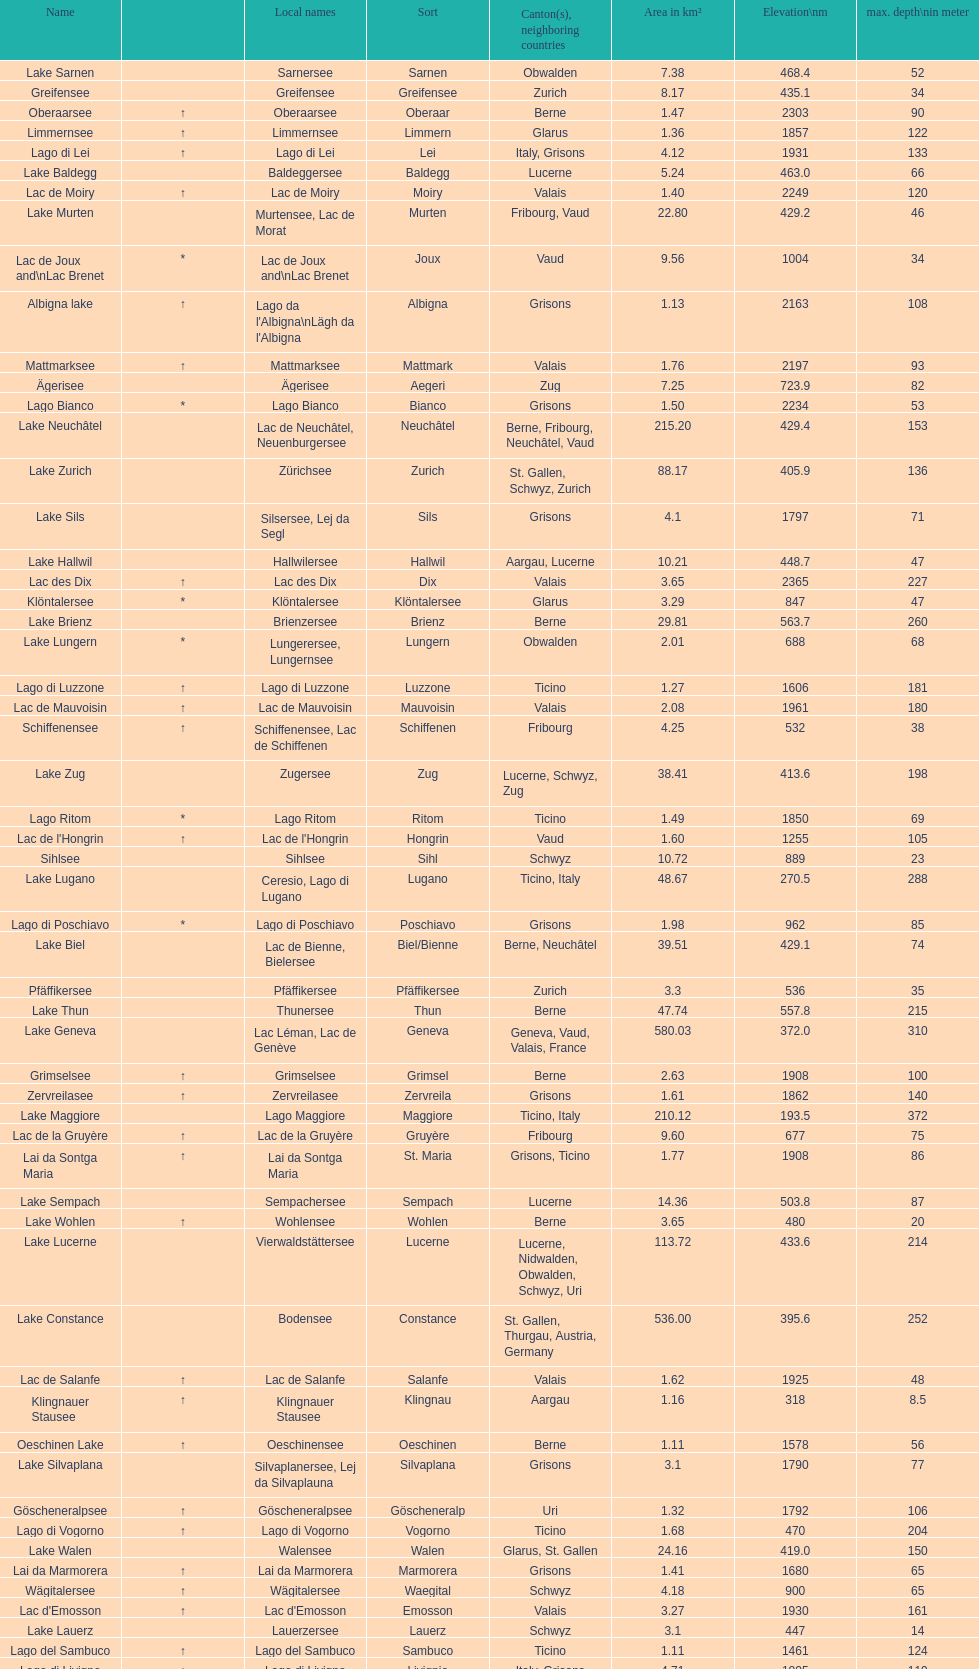Parse the full table. {'header': ['Name', '', 'Local names', 'Sort', 'Canton(s), neighboring countries', 'Area in km²', 'Elevation\\nm', 'max. depth\\nin meter'], 'rows': [['Lake Sarnen', '', 'Sarnersee', 'Sarnen', 'Obwalden', '7.38', '468.4', '52'], ['Greifensee', '', 'Greifensee', 'Greifensee', 'Zurich', '8.17', '435.1', '34'], ['Oberaarsee', '↑', 'Oberaarsee', 'Oberaar', 'Berne', '1.47', '2303', '90'], ['Limmernsee', '↑', 'Limmernsee', 'Limmern', 'Glarus', '1.36', '1857', '122'], ['Lago di Lei', '↑', 'Lago di Lei', 'Lei', 'Italy, Grisons', '4.12', '1931', '133'], ['Lake Baldegg', '', 'Baldeggersee', 'Baldegg', 'Lucerne', '5.24', '463.0', '66'], ['Lac de Moiry', '↑', 'Lac de Moiry', 'Moiry', 'Valais', '1.40', '2249', '120'], ['Lake Murten', '', 'Murtensee, Lac de Morat', 'Murten', 'Fribourg, Vaud', '22.80', '429.2', '46'], ['Lac de Joux and\\nLac Brenet', '*', 'Lac de Joux and\\nLac Brenet', 'Joux', 'Vaud', '9.56', '1004', '34'], ['Albigna lake', '↑', "Lago da l'Albigna\\nLägh da l'Albigna", 'Albigna', 'Grisons', '1.13', '2163', '108'], ['Mattmarksee', '↑', 'Mattmarksee', 'Mattmark', 'Valais', '1.76', '2197', '93'], ['Ägerisee', '', 'Ägerisee', 'Aegeri', 'Zug', '7.25', '723.9', '82'], ['Lago Bianco', '*', 'Lago Bianco', 'Bianco', 'Grisons', '1.50', '2234', '53'], ['Lake Neuchâtel', '', 'Lac de Neuchâtel, Neuenburgersee', 'Neuchâtel', 'Berne, Fribourg, Neuchâtel, Vaud', '215.20', '429.4', '153'], ['Lake Zurich', '', 'Zürichsee', 'Zurich', 'St. Gallen, Schwyz, Zurich', '88.17', '405.9', '136'], ['Lake Sils', '', 'Silsersee, Lej da Segl', 'Sils', 'Grisons', '4.1', '1797', '71'], ['Lake Hallwil', '', 'Hallwilersee', 'Hallwil', 'Aargau, Lucerne', '10.21', '448.7', '47'], ['Lac des Dix', '↑', 'Lac des Dix', 'Dix', 'Valais', '3.65', '2365', '227'], ['Klöntalersee', '*', 'Klöntalersee', 'Klöntalersee', 'Glarus', '3.29', '847', '47'], ['Lake Brienz', '', 'Brienzersee', 'Brienz', 'Berne', '29.81', '563.7', '260'], ['Lake Lungern', '*', 'Lungerersee, Lungernsee', 'Lungern', 'Obwalden', '2.01', '688', '68'], ['Lago di Luzzone', '↑', 'Lago di Luzzone', 'Luzzone', 'Ticino', '1.27', '1606', '181'], ['Lac de Mauvoisin', '↑', 'Lac de Mauvoisin', 'Mauvoisin', 'Valais', '2.08', '1961', '180'], ['Schiffenensee', '↑', 'Schiffenensee, Lac de Schiffenen', 'Schiffenen', 'Fribourg', '4.25', '532', '38'], ['Lake Zug', '', 'Zugersee', 'Zug', 'Lucerne, Schwyz, Zug', '38.41', '413.6', '198'], ['Lago Ritom', '*', 'Lago Ritom', 'Ritom', 'Ticino', '1.49', '1850', '69'], ["Lac de l'Hongrin", '↑', "Lac de l'Hongrin", 'Hongrin', 'Vaud', '1.60', '1255', '105'], ['Sihlsee', '', 'Sihlsee', 'Sihl', 'Schwyz', '10.72', '889', '23'], ['Lake Lugano', '', 'Ceresio, Lago di Lugano', 'Lugano', 'Ticino, Italy', '48.67', '270.5', '288'], ['Lago di Poschiavo', '*', 'Lago di Poschiavo', 'Poschiavo', 'Grisons', '1.98', '962', '85'], ['Lake Biel', '', 'Lac de Bienne, Bielersee', 'Biel/Bienne', 'Berne, Neuchâtel', '39.51', '429.1', '74'], ['Pfäffikersee', '', 'Pfäffikersee', 'Pfäffikersee', 'Zurich', '3.3', '536', '35'], ['Lake Thun', '', 'Thunersee', 'Thun', 'Berne', '47.74', '557.8', '215'], ['Lake Geneva', '', 'Lac Léman, Lac de Genève', 'Geneva', 'Geneva, Vaud, Valais, France', '580.03', '372.0', '310'], ['Grimselsee', '↑', 'Grimselsee', 'Grimsel', 'Berne', '2.63', '1908', '100'], ['Zervreilasee', '↑', 'Zervreilasee', 'Zervreila', 'Grisons', '1.61', '1862', '140'], ['Lake Maggiore', '', 'Lago Maggiore', 'Maggiore', 'Ticino, Italy', '210.12', '193.5', '372'], ['Lac de la Gruyère', '↑', 'Lac de la Gruyère', 'Gruyère', 'Fribourg', '9.60', '677', '75'], ['Lai da Sontga Maria', '↑', 'Lai da Sontga Maria', 'St. Maria', 'Grisons, Ticino', '1.77', '1908', '86'], ['Lake Sempach', '', 'Sempachersee', 'Sempach', 'Lucerne', '14.36', '503.8', '87'], ['Lake Wohlen', '↑', 'Wohlensee', 'Wohlen', 'Berne', '3.65', '480', '20'], ['Lake Lucerne', '', 'Vierwaldstättersee', 'Lucerne', 'Lucerne, Nidwalden, Obwalden, Schwyz, Uri', '113.72', '433.6', '214'], ['Lake Constance', '', 'Bodensee', 'Constance', 'St. Gallen, Thurgau, Austria, Germany', '536.00', '395.6', '252'], ['Lac de Salanfe', '↑', 'Lac de Salanfe', 'Salanfe', 'Valais', '1.62', '1925', '48'], ['Klingnauer Stausee', '↑', 'Klingnauer Stausee', 'Klingnau', 'Aargau', '1.16', '318', '8.5'], ['Oeschinen Lake', '↑', 'Oeschinensee', 'Oeschinen', 'Berne', '1.11', '1578', '56'], ['Lake Silvaplana', '', 'Silvaplanersee, Lej da Silvaplauna', 'Silvaplana', 'Grisons', '3.1', '1790', '77'], ['Göscheneralpsee', '↑', 'Göscheneralpsee', 'Göscheneralp', 'Uri', '1.32', '1792', '106'], ['Lago di Vogorno', '↑', 'Lago di Vogorno', 'Vogorno', 'Ticino', '1.68', '470', '204'], ['Lake Walen', '', 'Walensee', 'Walen', 'Glarus, St. Gallen', '24.16', '419.0', '150'], ['Lai da Marmorera', '↑', 'Lai da Marmorera', 'Marmorera', 'Grisons', '1.41', '1680', '65'], ['Wägitalersee', '↑', 'Wägitalersee', 'Waegital', 'Schwyz', '4.18', '900', '65'], ["Lac d'Emosson", '↑', "Lac d'Emosson", 'Emosson', 'Valais', '3.27', '1930', '161'], ['Lake Lauerz', '', 'Lauerzersee', 'Lauerz', 'Schwyz', '3.1', '447', '14'], ['Lago del Sambuco', '↑', 'Lago del Sambuco', 'Sambuco', 'Ticino', '1.11', '1461', '124'], ['Lago di Livigno', '↑', 'Lago di Livigno', 'Livignio', 'Italy, Grisons', '4.71', '1805', '119']]} Which is the only lake with a max depth of 372m? Lake Maggiore. 